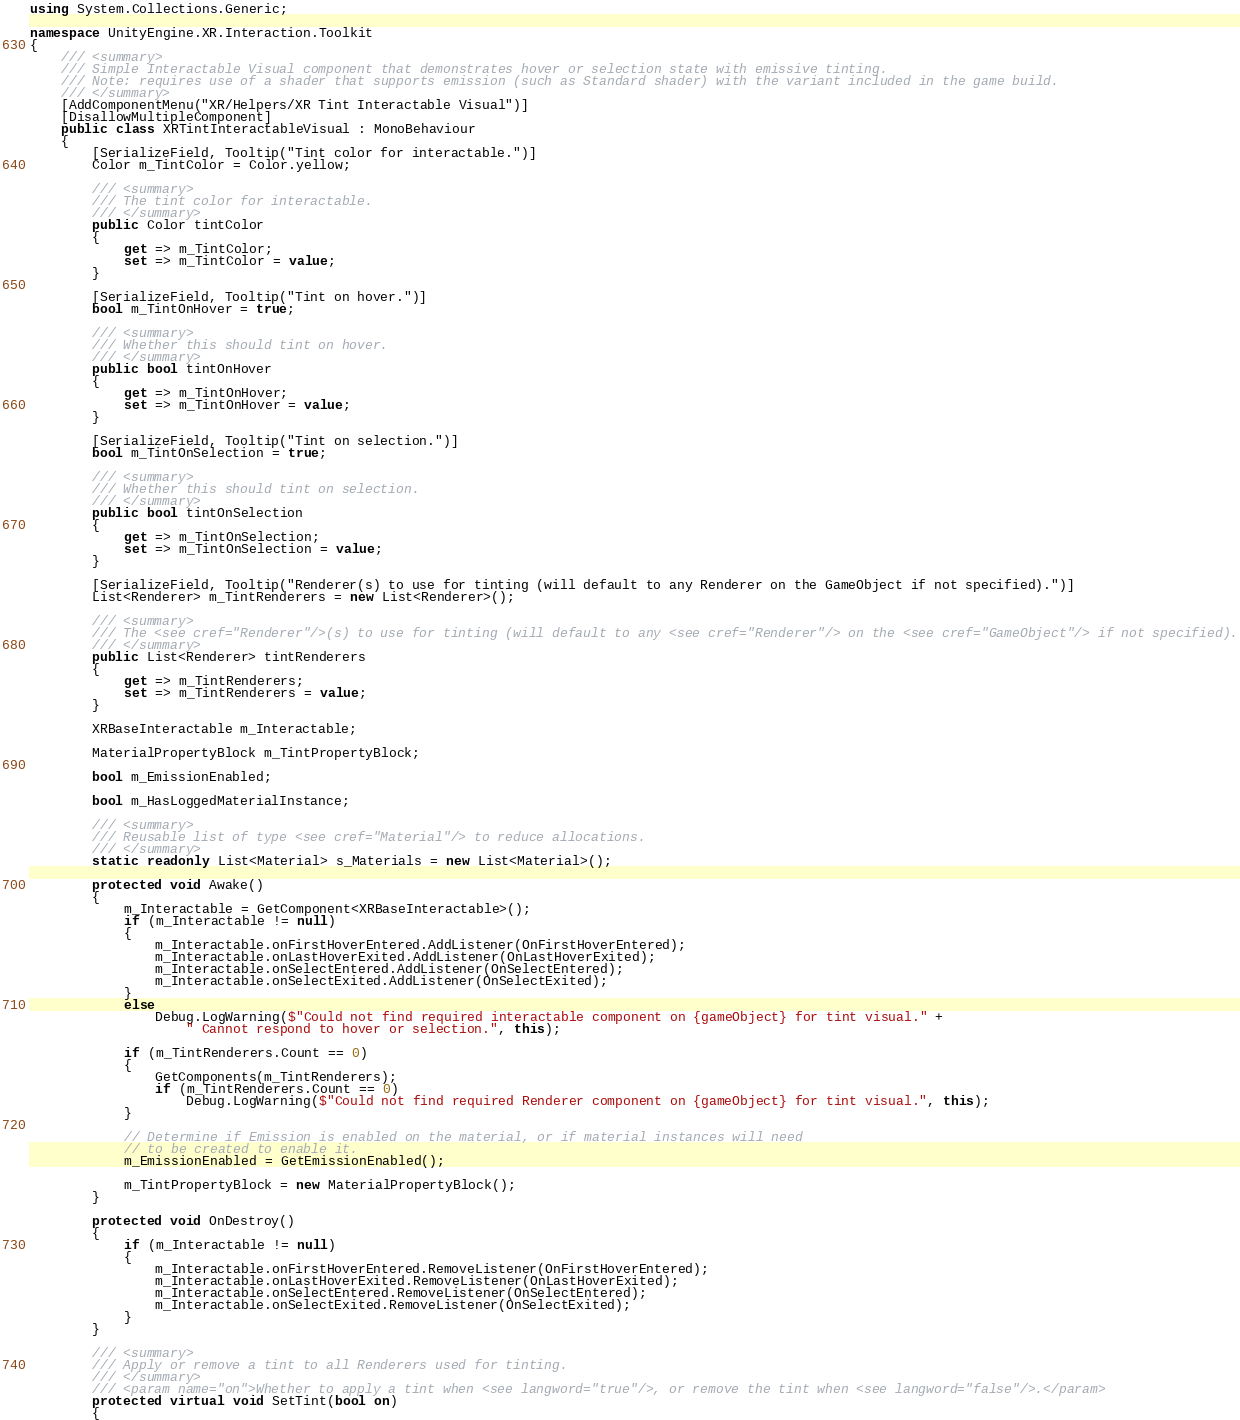<code> <loc_0><loc_0><loc_500><loc_500><_C#_>using System.Collections.Generic;

namespace UnityEngine.XR.Interaction.Toolkit
{
    /// <summary>
    /// Simple Interactable Visual component that demonstrates hover or selection state with emissive tinting.
    /// Note: requires use of a shader that supports emission (such as Standard shader) with the variant included in the game build.
    /// </summary>
    [AddComponentMenu("XR/Helpers/XR Tint Interactable Visual")]
    [DisallowMultipleComponent]
    public class XRTintInteractableVisual : MonoBehaviour
    {
        [SerializeField, Tooltip("Tint color for interactable.")]
        Color m_TintColor = Color.yellow;

        /// <summary>
        /// The tint color for interactable.
        /// </summary>
        public Color tintColor
        {
            get => m_TintColor;
            set => m_TintColor = value;
        }

        [SerializeField, Tooltip("Tint on hover.")]
        bool m_TintOnHover = true;

        /// <summary>
        /// Whether this should tint on hover.
        /// </summary>
        public bool tintOnHover
        {
            get => m_TintOnHover;
            set => m_TintOnHover = value;
        }

        [SerializeField, Tooltip("Tint on selection.")]
        bool m_TintOnSelection = true;

        /// <summary>
        /// Whether this should tint on selection.
        /// </summary>
        public bool tintOnSelection
        {
            get => m_TintOnSelection;
            set => m_TintOnSelection = value;
        }

        [SerializeField, Tooltip("Renderer(s) to use for tinting (will default to any Renderer on the GameObject if not specified).")]
        List<Renderer> m_TintRenderers = new List<Renderer>();

        /// <summary>
        /// The <see cref="Renderer"/>(s) to use for tinting (will default to any <see cref="Renderer"/> on the <see cref="GameObject"/> if not specified).
        /// </summary>
        public List<Renderer> tintRenderers
        {
            get => m_TintRenderers;
            set => m_TintRenderers = value;
        }

        XRBaseInteractable m_Interactable;

        MaterialPropertyBlock m_TintPropertyBlock;

        bool m_EmissionEnabled;

        bool m_HasLoggedMaterialInstance;

        /// <summary>
        /// Reusable list of type <see cref="Material"/> to reduce allocations.
        /// </summary>
        static readonly List<Material> s_Materials = new List<Material>();

        protected void Awake()
        {
            m_Interactable = GetComponent<XRBaseInteractable>();
            if (m_Interactable != null)
            {
                m_Interactable.onFirstHoverEntered.AddListener(OnFirstHoverEntered);
                m_Interactable.onLastHoverExited.AddListener(OnLastHoverExited);
                m_Interactable.onSelectEntered.AddListener(OnSelectEntered);
                m_Interactable.onSelectExited.AddListener(OnSelectExited);
            }
            else
                Debug.LogWarning($"Could not find required interactable component on {gameObject} for tint visual." +
                    " Cannot respond to hover or selection.", this);

            if (m_TintRenderers.Count == 0)
            {
                GetComponents(m_TintRenderers);
                if (m_TintRenderers.Count == 0)
                    Debug.LogWarning($"Could not find required Renderer component on {gameObject} for tint visual.", this);
            }

            // Determine if Emission is enabled on the material, or if material instances will need
            // to be created to enable it.
            m_EmissionEnabled = GetEmissionEnabled();

            m_TintPropertyBlock = new MaterialPropertyBlock();
        }

        protected void OnDestroy()
        {
            if (m_Interactable != null)
            {
                m_Interactable.onFirstHoverEntered.RemoveListener(OnFirstHoverEntered);
                m_Interactable.onLastHoverExited.RemoveListener(OnLastHoverExited);
                m_Interactable.onSelectEntered.RemoveListener(OnSelectEntered);
                m_Interactable.onSelectExited.RemoveListener(OnSelectExited);
            }
        }

        /// <summary>
        /// Apply or remove a tint to all Renderers used for tinting.
        /// </summary>
        /// <param name="on">Whether to apply a tint when <see langword="true"/>, or remove the tint when <see langword="false"/>.</param>
        protected virtual void SetTint(bool on)
        {</code> 